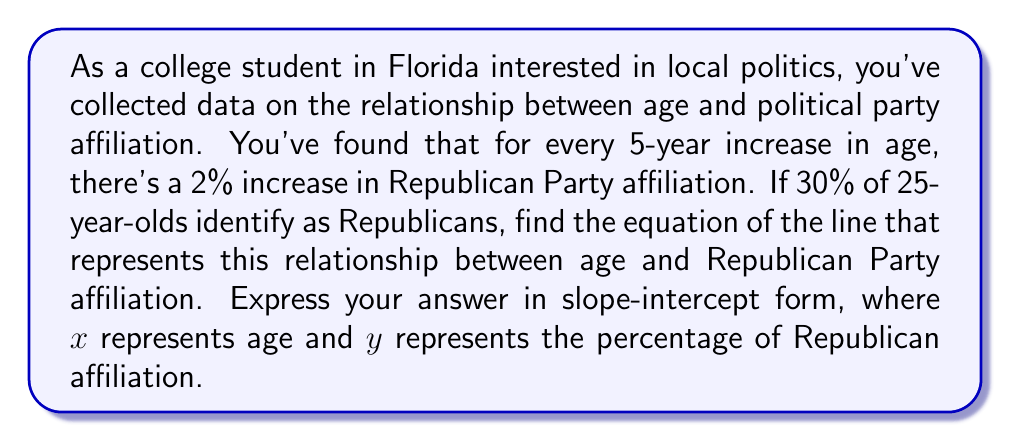Could you help me with this problem? Let's approach this step-by-step:

1) First, let's identify the given information:
   - For every 5-year increase in age, there's a 2% increase in Republican affiliation
   - At age 25, 30% identify as Republicans

2) We need to find the slope (m) of the line:
   $m = \frac{\text{change in y}}{\text{change in x}} = \frac{2\%}{5 \text{ years}} = 0.4\% \text{ per year}$

3) Now we can write the equation in point-slope form:
   $y - y_1 = m(x - x_1)$
   Where $(x_1, y_1)$ is the known point (25, 30)

4) Substituting our values:
   $y - 30 = 0.4(x - 25)$

5) Expand the equation:
   $y - 30 = 0.4x - 10$

6) Add 30 to both sides to get y by itself:
   $y = 0.4x - 10 + 30$

7) Simplify:
   $y = 0.4x + 20$

This equation is now in slope-intercept form $(y = mx + b)$, where:
- $m = 0.4$ is the slope
- $b = 20$ is the y-intercept

This means that at age 0 (the y-intercept), the model predicts 20% Republican affiliation, which increases by 0.4% for each year of age.
Answer: $y = 0.4x + 20$, where $x$ is age and $y$ is the percentage of Republican affiliation 